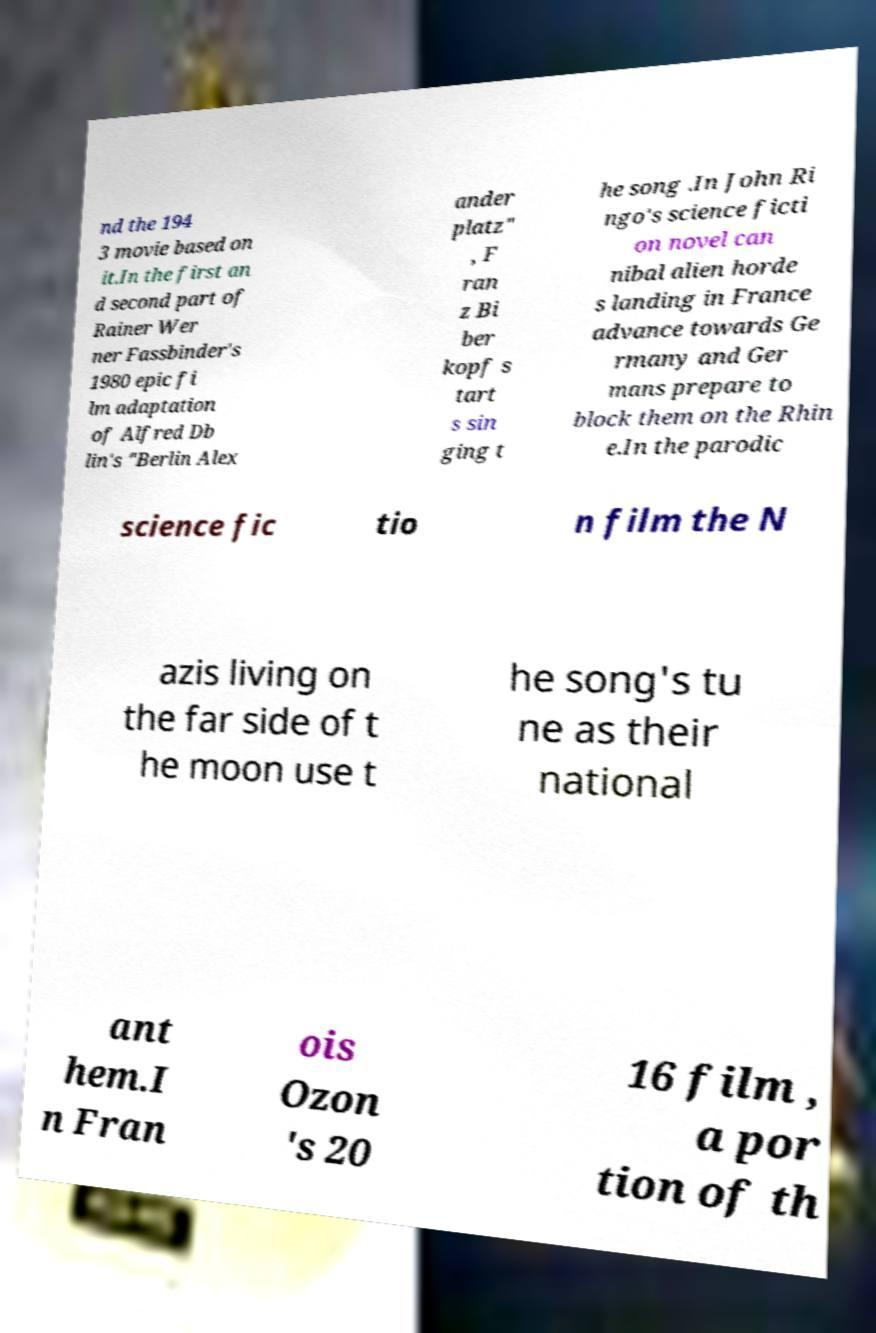Please identify and transcribe the text found in this image. nd the 194 3 movie based on it.In the first an d second part of Rainer Wer ner Fassbinder's 1980 epic fi lm adaptation of Alfred Db lin's "Berlin Alex ander platz" , F ran z Bi ber kopf s tart s sin ging t he song .In John Ri ngo's science ficti on novel can nibal alien horde s landing in France advance towards Ge rmany and Ger mans prepare to block them on the Rhin e.In the parodic science fic tio n film the N azis living on the far side of t he moon use t he song's tu ne as their national ant hem.I n Fran ois Ozon 's 20 16 film , a por tion of th 